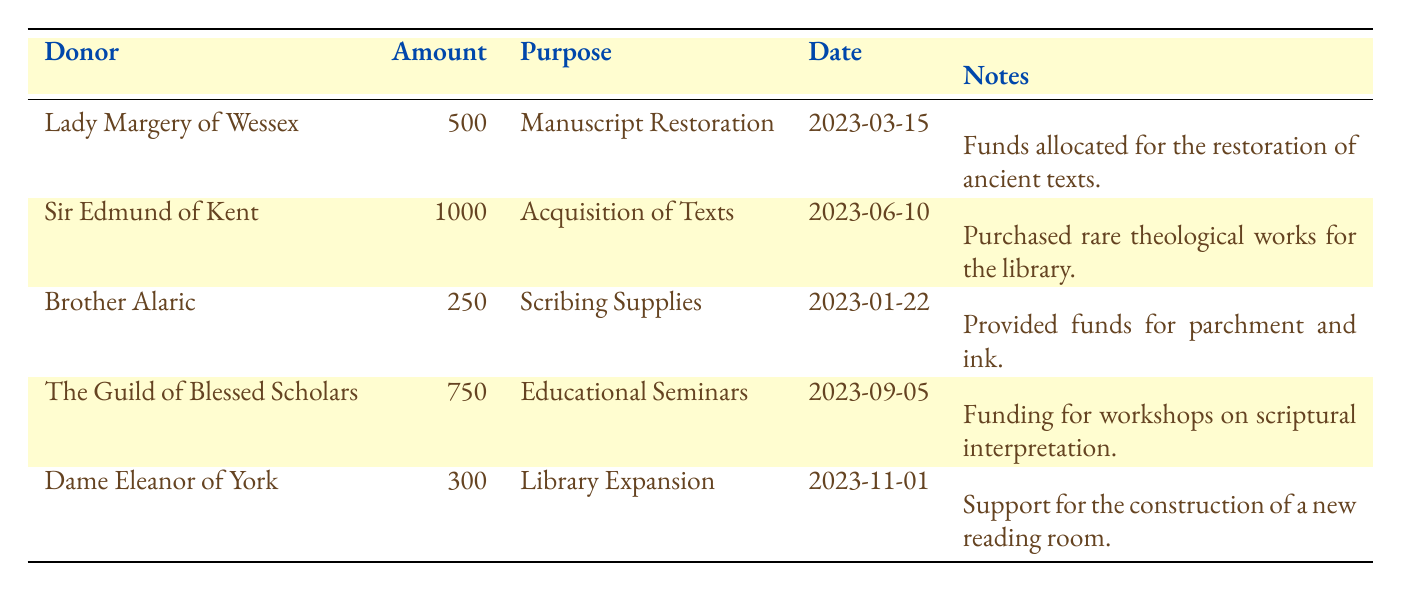What is the total amount of contributions received from all donors? To find the total amount, we sum all the contributions listed: 500 + 1000 + 250 + 750 + 300 = 2800.
Answer: 2800 Which purpose received the highest funding? By examining the 'Amount' column, Sir Edmund of Kent's contribution of 1000 for 'Acquisition of Texts' is the highest compared to other amounts.
Answer: Acquisition of Texts Did Brother Alaric donate more than Lady Margery of Wessex? Brother Alaric contributed 250, while Lady Margery of Wessex contributed 500. Since 250 is less than 500, the answer is no.
Answer: No How many donations were provided for educational purposes? Two donations are aimed at education: the Guild of Blessed Scholars contributed 750 for 'Educational Seminars' and Sir Edmund of Kent contributed for 'Acquisition of Texts,' which could be educational too. Thus, counting both contributions we get a total of two educational donations.
Answer: 2 What is the average contribution amount among donors? To find the average, first calculate the total contributions which is 2800, then divide this by the number of donors which is 5. So, 2800 / 5 = 560.
Answer: 560 Is there a donation specifically for scribing supplies? Yes, there is a specific donation for scribing supplies made by Brother Alaric, who contributed 250 for this purpose, confirming that such a donation exists.
Answer: Yes Which donor contributed the least amount and what was the purpose? Looking at the 'Amount' column, Brother Alaric with 250 contributed the least, and the purpose for this donation was 'Scribing Supplies.'
Answer: Brother Alaric, Scribing Supplies If we exclude Dame Eleanor of York's contribution, what would be the new total of contributions? The original total is 2800. Dame Eleanor of York contributed 300, so the new total would be 2800 - 300 = 2500.
Answer: 2500 